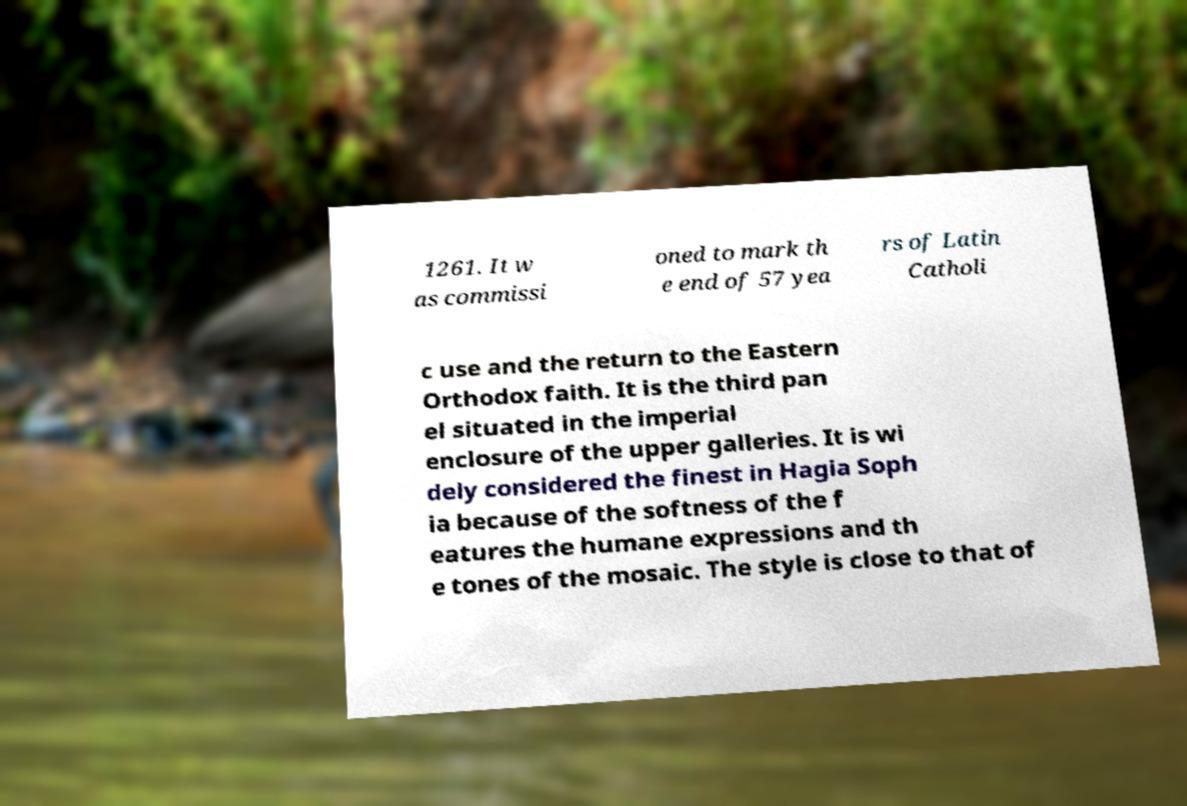What messages or text are displayed in this image? I need them in a readable, typed format. 1261. It w as commissi oned to mark th e end of 57 yea rs of Latin Catholi c use and the return to the Eastern Orthodox faith. It is the third pan el situated in the imperial enclosure of the upper galleries. It is wi dely considered the finest in Hagia Soph ia because of the softness of the f eatures the humane expressions and th e tones of the mosaic. The style is close to that of 